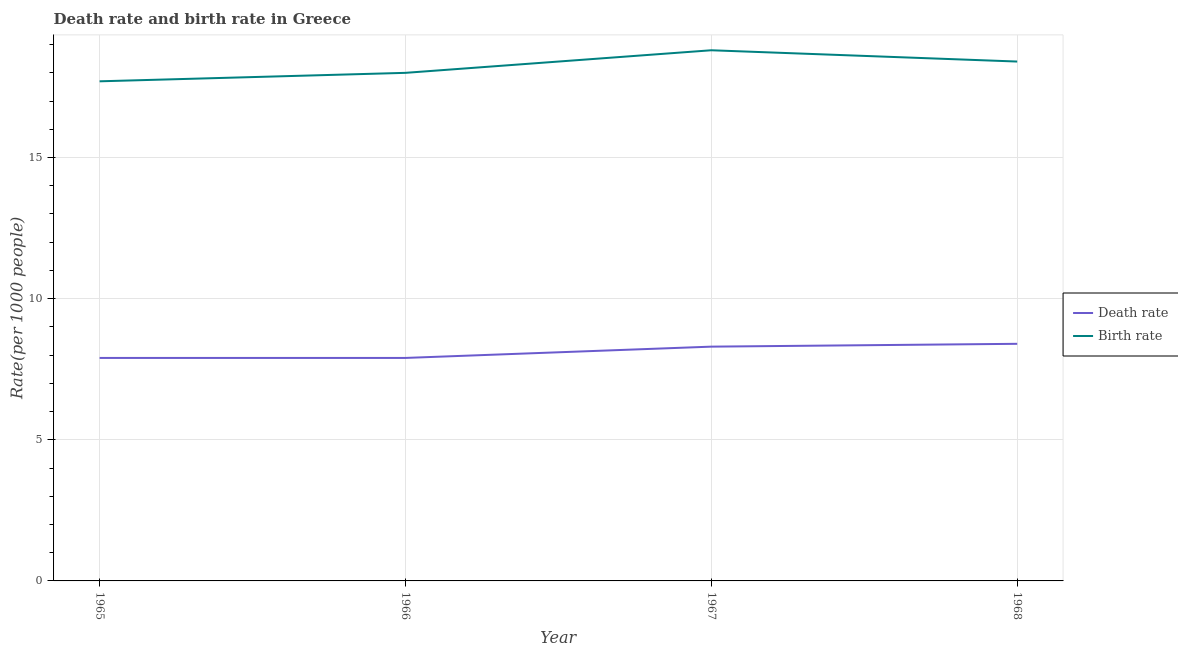Does the line corresponding to birth rate intersect with the line corresponding to death rate?
Ensure brevity in your answer.  No. Is the number of lines equal to the number of legend labels?
Provide a succinct answer. Yes. In which year was the birth rate maximum?
Your answer should be very brief. 1967. In which year was the birth rate minimum?
Give a very brief answer. 1965. What is the total birth rate in the graph?
Your response must be concise. 72.9. What is the difference between the death rate in 1966 and that in 1967?
Ensure brevity in your answer.  -0.4. What is the average death rate per year?
Your response must be concise. 8.12. In how many years, is the birth rate greater than 8?
Your answer should be compact. 4. What is the ratio of the birth rate in 1966 to that in 1967?
Keep it short and to the point. 0.96. Is the death rate in 1966 less than that in 1967?
Give a very brief answer. Yes. Is the difference between the death rate in 1965 and 1966 greater than the difference between the birth rate in 1965 and 1966?
Ensure brevity in your answer.  Yes. What is the difference between the highest and the second highest death rate?
Keep it short and to the point. 0.1. What is the difference between the highest and the lowest birth rate?
Give a very brief answer. 1.1. In how many years, is the birth rate greater than the average birth rate taken over all years?
Make the answer very short. 2. Is the sum of the birth rate in 1966 and 1967 greater than the maximum death rate across all years?
Offer a terse response. Yes. Does the birth rate monotonically increase over the years?
Your answer should be compact. No. Is the birth rate strictly greater than the death rate over the years?
Give a very brief answer. Yes. Is the birth rate strictly less than the death rate over the years?
Ensure brevity in your answer.  No. How many lines are there?
Ensure brevity in your answer.  2. Are the values on the major ticks of Y-axis written in scientific E-notation?
Ensure brevity in your answer.  No. Does the graph contain any zero values?
Provide a short and direct response. No. What is the title of the graph?
Offer a very short reply. Death rate and birth rate in Greece. What is the label or title of the Y-axis?
Provide a short and direct response. Rate(per 1000 people). What is the Rate(per 1000 people) in Death rate in 1965?
Keep it short and to the point. 7.9. What is the Rate(per 1000 people) in Birth rate in 1965?
Offer a very short reply. 17.7. What is the Rate(per 1000 people) of Death rate in 1966?
Provide a succinct answer. 7.9. What is the Rate(per 1000 people) of Birth rate in 1966?
Offer a terse response. 18. What is the Rate(per 1000 people) in Death rate in 1968?
Keep it short and to the point. 8.4. What is the Rate(per 1000 people) in Birth rate in 1968?
Ensure brevity in your answer.  18.4. Across all years, what is the maximum Rate(per 1000 people) of Birth rate?
Offer a terse response. 18.8. Across all years, what is the minimum Rate(per 1000 people) in Birth rate?
Ensure brevity in your answer.  17.7. What is the total Rate(per 1000 people) of Death rate in the graph?
Give a very brief answer. 32.5. What is the total Rate(per 1000 people) in Birth rate in the graph?
Provide a succinct answer. 72.9. What is the difference between the Rate(per 1000 people) in Death rate in 1965 and that in 1966?
Your response must be concise. 0. What is the difference between the Rate(per 1000 people) of Birth rate in 1965 and that in 1966?
Offer a very short reply. -0.3. What is the difference between the Rate(per 1000 people) of Death rate in 1965 and that in 1967?
Offer a very short reply. -0.4. What is the difference between the Rate(per 1000 people) of Birth rate in 1965 and that in 1967?
Provide a succinct answer. -1.1. What is the difference between the Rate(per 1000 people) in Death rate in 1965 and that in 1968?
Your answer should be very brief. -0.5. What is the difference between the Rate(per 1000 people) in Death rate in 1966 and that in 1968?
Make the answer very short. -0.5. What is the difference between the Rate(per 1000 people) of Birth rate in 1966 and that in 1968?
Your answer should be compact. -0.4. What is the difference between the Rate(per 1000 people) of Death rate in 1967 and that in 1968?
Keep it short and to the point. -0.1. What is the difference between the Rate(per 1000 people) of Birth rate in 1967 and that in 1968?
Your answer should be very brief. 0.4. What is the difference between the Rate(per 1000 people) in Death rate in 1965 and the Rate(per 1000 people) in Birth rate in 1968?
Make the answer very short. -10.5. What is the difference between the Rate(per 1000 people) in Death rate in 1966 and the Rate(per 1000 people) in Birth rate in 1967?
Your response must be concise. -10.9. What is the difference between the Rate(per 1000 people) of Death rate in 1966 and the Rate(per 1000 people) of Birth rate in 1968?
Provide a succinct answer. -10.5. What is the difference between the Rate(per 1000 people) of Death rate in 1967 and the Rate(per 1000 people) of Birth rate in 1968?
Ensure brevity in your answer.  -10.1. What is the average Rate(per 1000 people) in Death rate per year?
Your response must be concise. 8.12. What is the average Rate(per 1000 people) in Birth rate per year?
Give a very brief answer. 18.23. In the year 1965, what is the difference between the Rate(per 1000 people) of Death rate and Rate(per 1000 people) of Birth rate?
Ensure brevity in your answer.  -9.8. In the year 1966, what is the difference between the Rate(per 1000 people) in Death rate and Rate(per 1000 people) in Birth rate?
Offer a very short reply. -10.1. In the year 1967, what is the difference between the Rate(per 1000 people) in Death rate and Rate(per 1000 people) in Birth rate?
Your answer should be compact. -10.5. What is the ratio of the Rate(per 1000 people) of Death rate in 1965 to that in 1966?
Your answer should be very brief. 1. What is the ratio of the Rate(per 1000 people) of Birth rate in 1965 to that in 1966?
Ensure brevity in your answer.  0.98. What is the ratio of the Rate(per 1000 people) of Death rate in 1965 to that in 1967?
Offer a terse response. 0.95. What is the ratio of the Rate(per 1000 people) of Birth rate in 1965 to that in 1967?
Your answer should be very brief. 0.94. What is the ratio of the Rate(per 1000 people) of Death rate in 1965 to that in 1968?
Give a very brief answer. 0.94. What is the ratio of the Rate(per 1000 people) of Death rate in 1966 to that in 1967?
Keep it short and to the point. 0.95. What is the ratio of the Rate(per 1000 people) in Birth rate in 1966 to that in 1967?
Offer a very short reply. 0.96. What is the ratio of the Rate(per 1000 people) of Death rate in 1966 to that in 1968?
Provide a short and direct response. 0.94. What is the ratio of the Rate(per 1000 people) of Birth rate in 1966 to that in 1968?
Give a very brief answer. 0.98. What is the ratio of the Rate(per 1000 people) of Death rate in 1967 to that in 1968?
Make the answer very short. 0.99. What is the ratio of the Rate(per 1000 people) in Birth rate in 1967 to that in 1968?
Offer a very short reply. 1.02. What is the difference between the highest and the second highest Rate(per 1000 people) of Death rate?
Give a very brief answer. 0.1. What is the difference between the highest and the second highest Rate(per 1000 people) in Birth rate?
Give a very brief answer. 0.4. What is the difference between the highest and the lowest Rate(per 1000 people) in Death rate?
Provide a short and direct response. 0.5. What is the difference between the highest and the lowest Rate(per 1000 people) in Birth rate?
Your answer should be very brief. 1.1. 